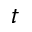Convert formula to latex. <formula><loc_0><loc_0><loc_500><loc_500>t</formula> 